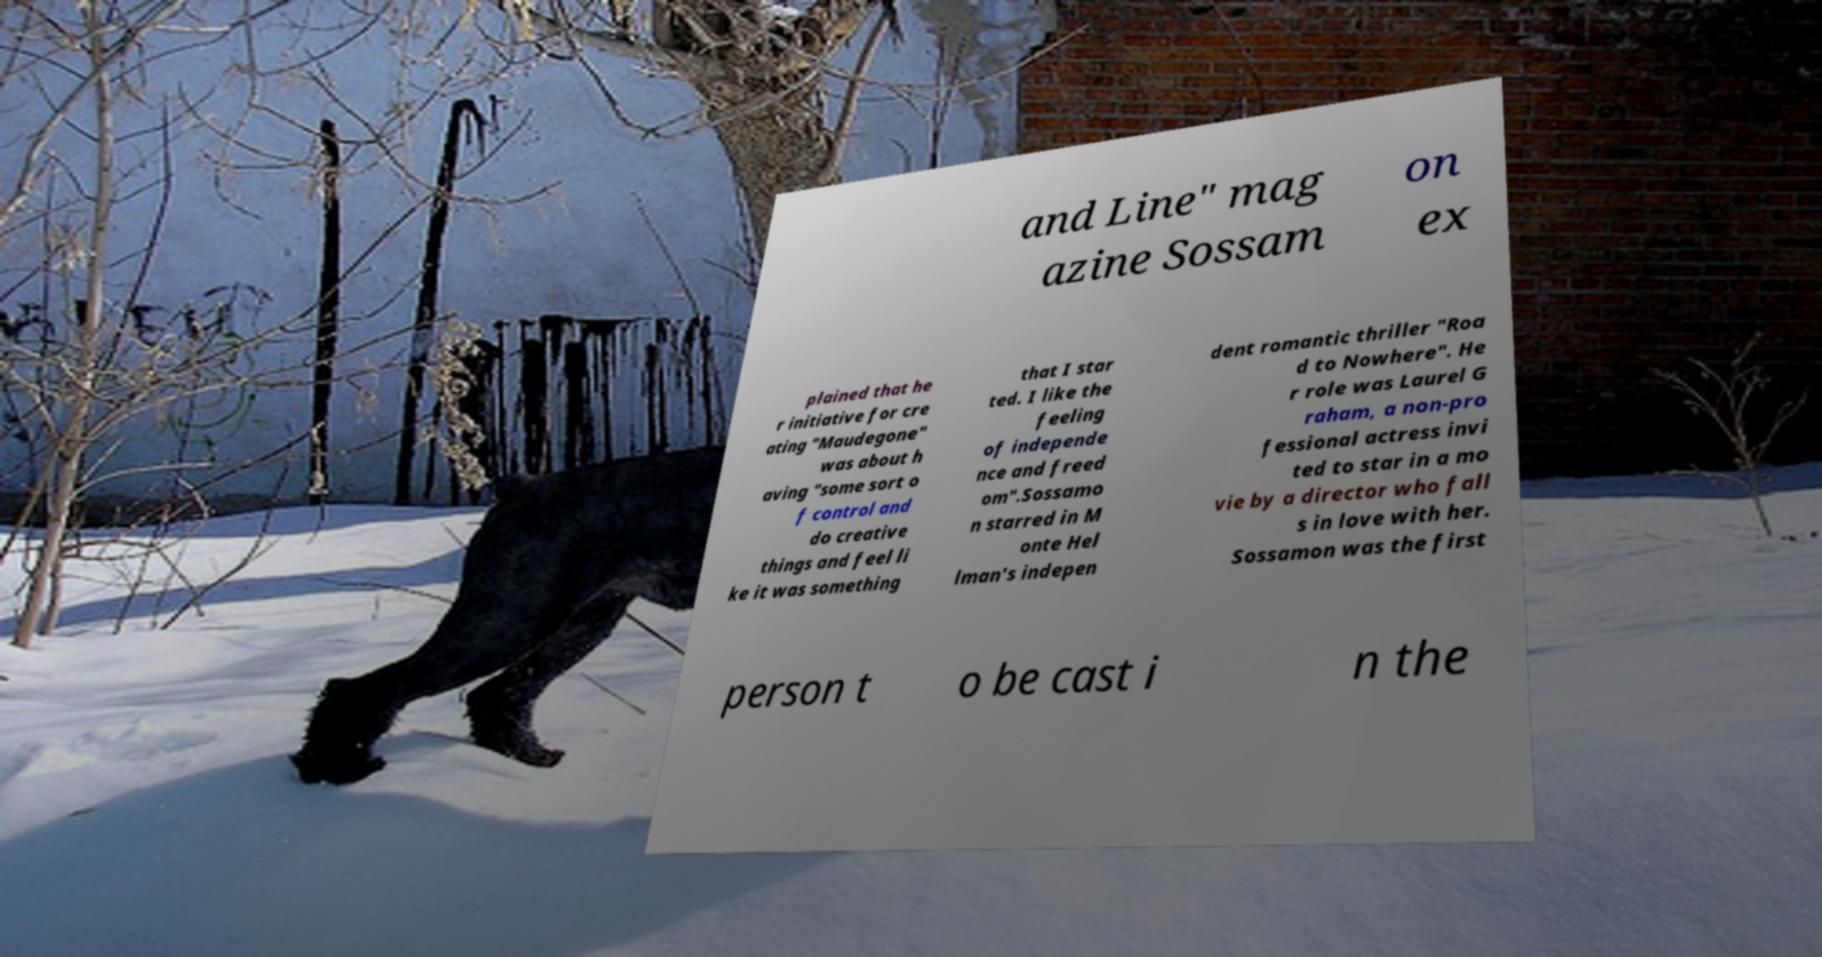Please identify and transcribe the text found in this image. and Line" mag azine Sossam on ex plained that he r initiative for cre ating "Maudegone" was about h aving "some sort o f control and do creative things and feel li ke it was something that I star ted. I like the feeling of independe nce and freed om".Sossamo n starred in M onte Hel lman's indepen dent romantic thriller "Roa d to Nowhere". He r role was Laurel G raham, a non-pro fessional actress invi ted to star in a mo vie by a director who fall s in love with her. Sossamon was the first person t o be cast i n the 